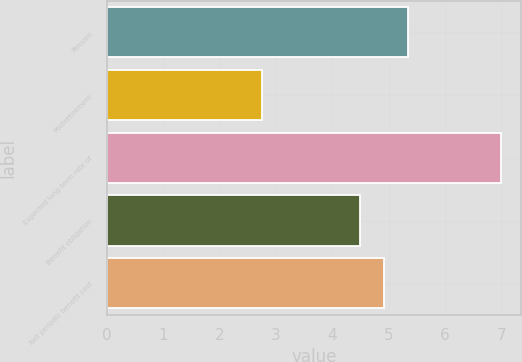Convert chart. <chart><loc_0><loc_0><loc_500><loc_500><bar_chart><fcel>Pension<fcel>Postretirement<fcel>Expected long-term rate of<fcel>Benefit obligation<fcel>Net periodic benefit cost<nl><fcel>5.34<fcel>2.76<fcel>7<fcel>4.5<fcel>4.92<nl></chart> 